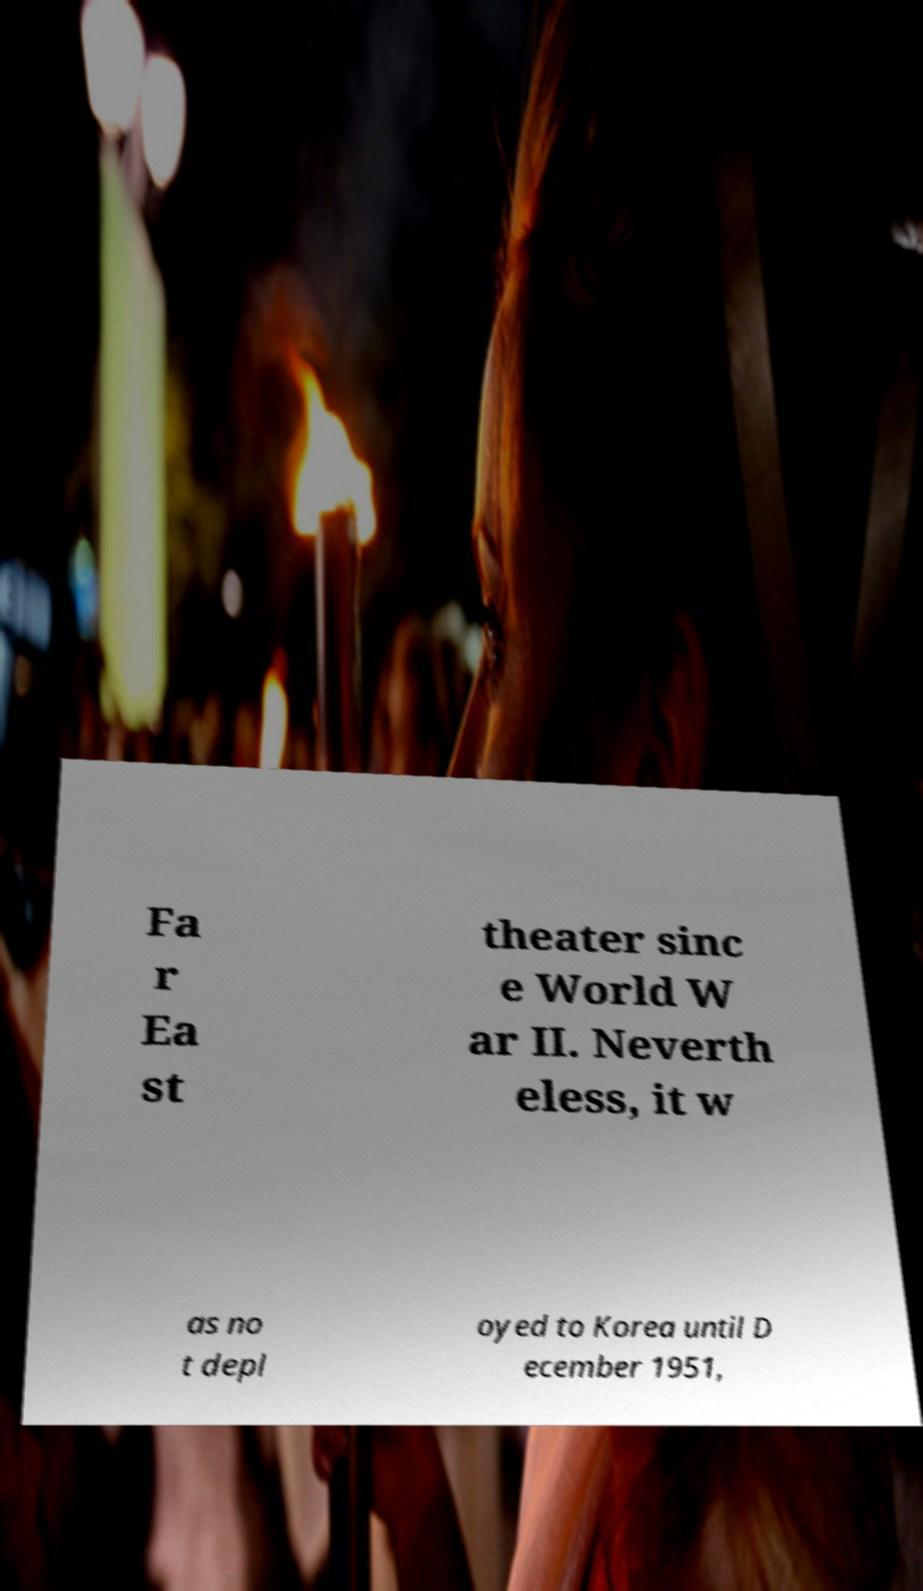Please identify and transcribe the text found in this image. Fa r Ea st theater sinc e World W ar II. Neverth eless, it w as no t depl oyed to Korea until D ecember 1951, 